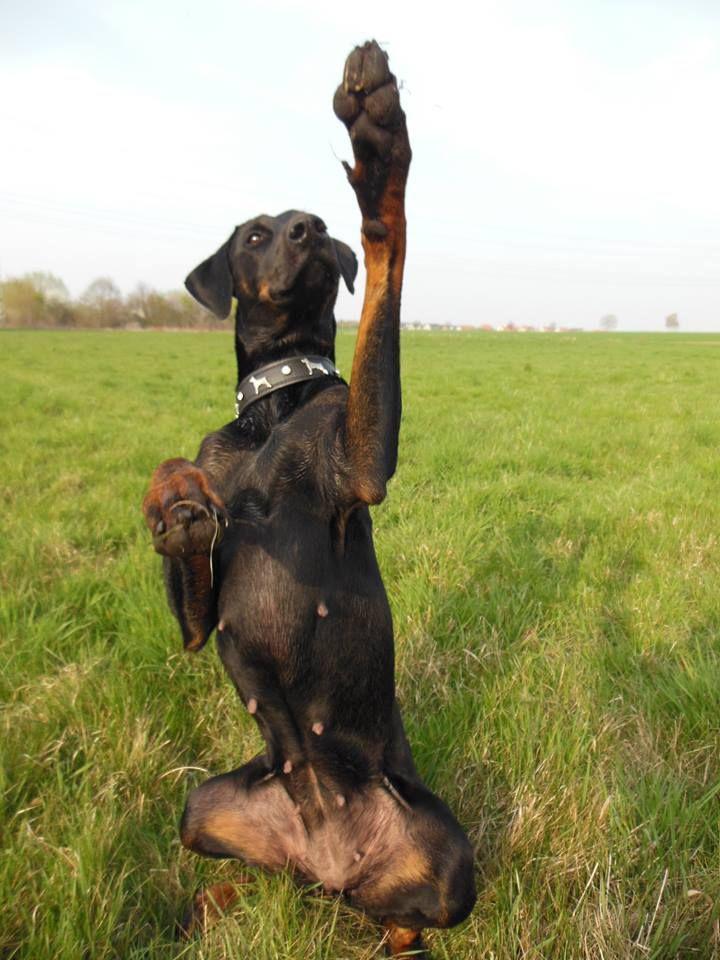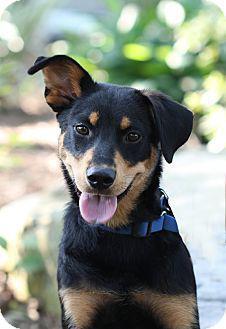The first image is the image on the left, the second image is the image on the right. Given the left and right images, does the statement "One dog is sitting and isn't wearing a dog collar." hold true? Answer yes or no. No. The first image is the image on the left, the second image is the image on the right. Analyze the images presented: Is the assertion "At least one image features an adult doberman with erect pointy ears in an upright sitting position." valid? Answer yes or no. No. 